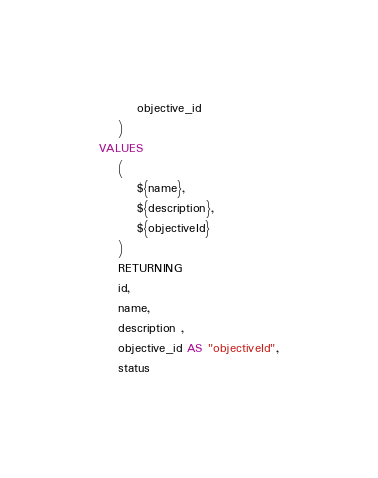Convert code to text. <code><loc_0><loc_0><loc_500><loc_500><_SQL_>        objective_id
    )
VALUES
    (
        ${name},
        ${description},
        ${objectiveId}
    ) 
    RETURNING 
    id,
    name,
    description ,
    objective_id AS "objectiveId",
    status
</code> 